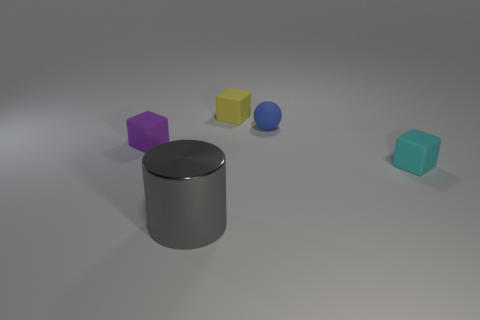Add 3 blue rubber spheres. How many objects exist? 8 Subtract all cylinders. How many objects are left? 4 Add 3 balls. How many balls exist? 4 Subtract 0 red spheres. How many objects are left? 5 Subtract all gray things. Subtract all big cyan objects. How many objects are left? 4 Add 4 gray shiny cylinders. How many gray shiny cylinders are left? 5 